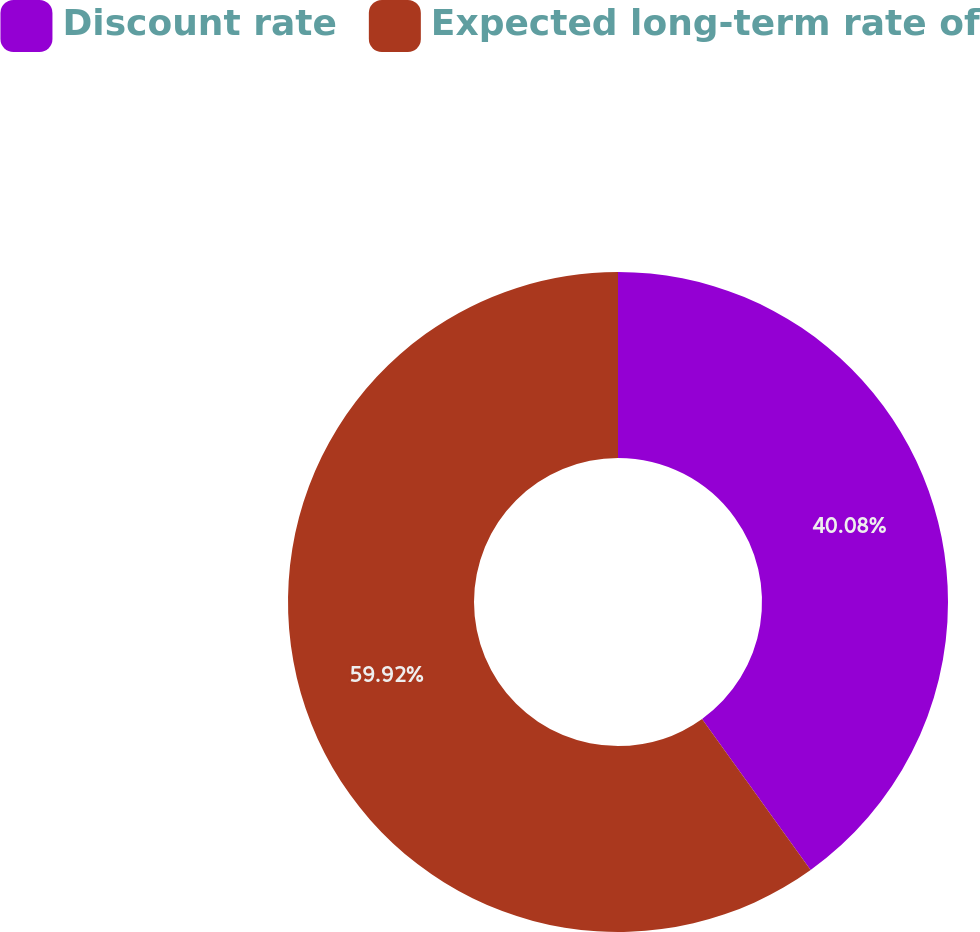Convert chart to OTSL. <chart><loc_0><loc_0><loc_500><loc_500><pie_chart><fcel>Discount rate<fcel>Expected long-term rate of<nl><fcel>40.08%<fcel>59.92%<nl></chart> 